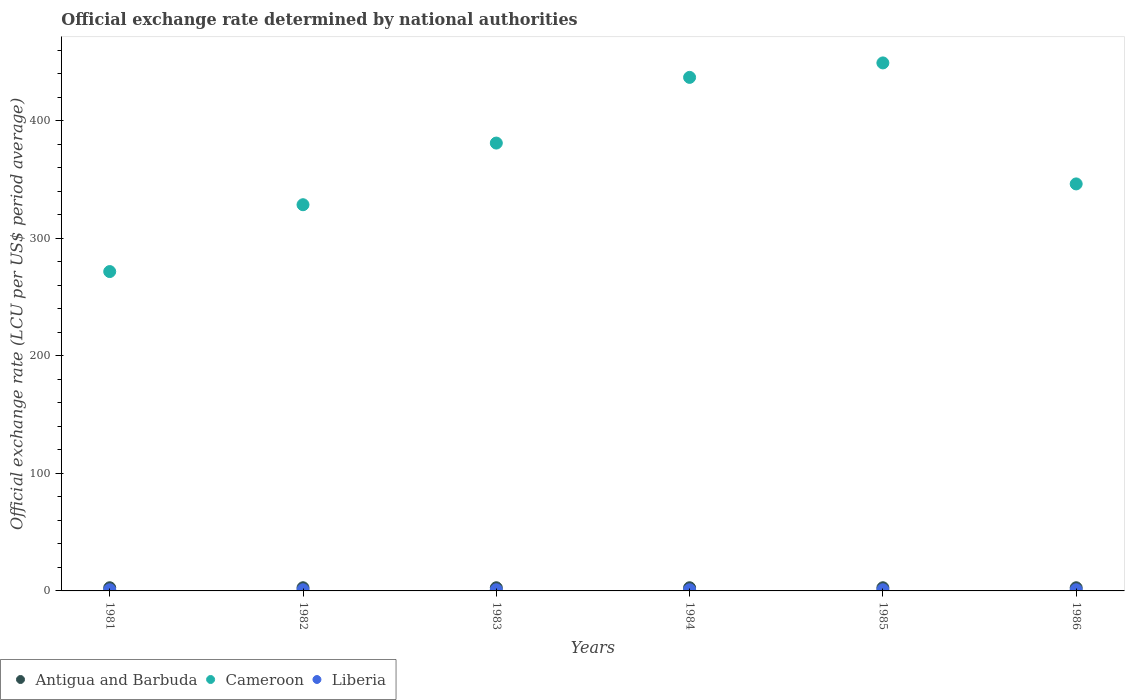What is the official exchange rate in Liberia in 1984?
Your answer should be compact. 1. Across all years, what is the maximum official exchange rate in Cameroon?
Your answer should be compact. 449.26. Across all years, what is the minimum official exchange rate in Liberia?
Offer a terse response. 1. In which year was the official exchange rate in Antigua and Barbuda maximum?
Your answer should be very brief. 1981. In which year was the official exchange rate in Antigua and Barbuda minimum?
Make the answer very short. 1981. What is the difference between the official exchange rate in Liberia in 1986 and the official exchange rate in Cameroon in 1982?
Your response must be concise. -327.61. What is the average official exchange rate in Liberia per year?
Provide a short and direct response. 1. In the year 1984, what is the difference between the official exchange rate in Antigua and Barbuda and official exchange rate in Cameroon?
Your response must be concise. -434.26. In how many years, is the official exchange rate in Liberia greater than 380 LCU?
Give a very brief answer. 0. What is the ratio of the official exchange rate in Cameroon in 1982 to that in 1985?
Ensure brevity in your answer.  0.73. What is the difference between the highest and the second highest official exchange rate in Antigua and Barbuda?
Ensure brevity in your answer.  0. What is the difference between the highest and the lowest official exchange rate in Antigua and Barbuda?
Your answer should be very brief. 0. In how many years, is the official exchange rate in Antigua and Barbuda greater than the average official exchange rate in Antigua and Barbuda taken over all years?
Provide a short and direct response. 6. Is it the case that in every year, the sum of the official exchange rate in Liberia and official exchange rate in Antigua and Barbuda  is greater than the official exchange rate in Cameroon?
Your answer should be compact. No. Does the official exchange rate in Antigua and Barbuda monotonically increase over the years?
Make the answer very short. No. How many years are there in the graph?
Your response must be concise. 6. What is the difference between two consecutive major ticks on the Y-axis?
Offer a very short reply. 100. Are the values on the major ticks of Y-axis written in scientific E-notation?
Provide a short and direct response. No. Does the graph contain any zero values?
Your answer should be compact. No. Where does the legend appear in the graph?
Offer a terse response. Bottom left. How are the legend labels stacked?
Your response must be concise. Horizontal. What is the title of the graph?
Make the answer very short. Official exchange rate determined by national authorities. What is the label or title of the Y-axis?
Offer a very short reply. Official exchange rate (LCU per US$ period average). What is the Official exchange rate (LCU per US$ period average) of Cameroon in 1981?
Give a very brief answer. 271.73. What is the Official exchange rate (LCU per US$ period average) in Liberia in 1981?
Make the answer very short. 1. What is the Official exchange rate (LCU per US$ period average) in Antigua and Barbuda in 1982?
Make the answer very short. 2.7. What is the Official exchange rate (LCU per US$ period average) of Cameroon in 1982?
Offer a terse response. 328.61. What is the Official exchange rate (LCU per US$ period average) of Liberia in 1982?
Keep it short and to the point. 1. What is the Official exchange rate (LCU per US$ period average) of Antigua and Barbuda in 1983?
Offer a very short reply. 2.7. What is the Official exchange rate (LCU per US$ period average) in Cameroon in 1983?
Offer a very short reply. 381.07. What is the Official exchange rate (LCU per US$ period average) of Liberia in 1983?
Offer a terse response. 1. What is the Official exchange rate (LCU per US$ period average) in Cameroon in 1984?
Ensure brevity in your answer.  436.96. What is the Official exchange rate (LCU per US$ period average) of Liberia in 1984?
Provide a short and direct response. 1. What is the Official exchange rate (LCU per US$ period average) of Antigua and Barbuda in 1985?
Your answer should be compact. 2.7. What is the Official exchange rate (LCU per US$ period average) in Cameroon in 1985?
Keep it short and to the point. 449.26. What is the Official exchange rate (LCU per US$ period average) of Liberia in 1985?
Keep it short and to the point. 1. What is the Official exchange rate (LCU per US$ period average) of Antigua and Barbuda in 1986?
Provide a succinct answer. 2.7. What is the Official exchange rate (LCU per US$ period average) in Cameroon in 1986?
Keep it short and to the point. 346.31. What is the Official exchange rate (LCU per US$ period average) in Liberia in 1986?
Give a very brief answer. 1. Across all years, what is the maximum Official exchange rate (LCU per US$ period average) of Cameroon?
Your answer should be very brief. 449.26. Across all years, what is the maximum Official exchange rate (LCU per US$ period average) of Liberia?
Keep it short and to the point. 1. Across all years, what is the minimum Official exchange rate (LCU per US$ period average) in Antigua and Barbuda?
Ensure brevity in your answer.  2.7. Across all years, what is the minimum Official exchange rate (LCU per US$ period average) in Cameroon?
Provide a short and direct response. 271.73. Across all years, what is the minimum Official exchange rate (LCU per US$ period average) of Liberia?
Offer a very short reply. 1. What is the total Official exchange rate (LCU per US$ period average) of Cameroon in the graph?
Ensure brevity in your answer.  2213.93. What is the difference between the Official exchange rate (LCU per US$ period average) of Antigua and Barbuda in 1981 and that in 1982?
Your answer should be very brief. 0. What is the difference between the Official exchange rate (LCU per US$ period average) in Cameroon in 1981 and that in 1982?
Provide a short and direct response. -56.87. What is the difference between the Official exchange rate (LCU per US$ period average) of Cameroon in 1981 and that in 1983?
Give a very brief answer. -109.33. What is the difference between the Official exchange rate (LCU per US$ period average) of Cameroon in 1981 and that in 1984?
Offer a very short reply. -165.23. What is the difference between the Official exchange rate (LCU per US$ period average) in Antigua and Barbuda in 1981 and that in 1985?
Your response must be concise. 0. What is the difference between the Official exchange rate (LCU per US$ period average) in Cameroon in 1981 and that in 1985?
Offer a terse response. -177.53. What is the difference between the Official exchange rate (LCU per US$ period average) of Liberia in 1981 and that in 1985?
Provide a short and direct response. -0. What is the difference between the Official exchange rate (LCU per US$ period average) in Cameroon in 1981 and that in 1986?
Ensure brevity in your answer.  -74.57. What is the difference between the Official exchange rate (LCU per US$ period average) of Cameroon in 1982 and that in 1983?
Ensure brevity in your answer.  -52.46. What is the difference between the Official exchange rate (LCU per US$ period average) of Liberia in 1982 and that in 1983?
Your response must be concise. 0. What is the difference between the Official exchange rate (LCU per US$ period average) of Cameroon in 1982 and that in 1984?
Provide a short and direct response. -108.35. What is the difference between the Official exchange rate (LCU per US$ period average) of Antigua and Barbuda in 1982 and that in 1985?
Provide a succinct answer. 0. What is the difference between the Official exchange rate (LCU per US$ period average) in Cameroon in 1982 and that in 1985?
Your response must be concise. -120.66. What is the difference between the Official exchange rate (LCU per US$ period average) in Cameroon in 1982 and that in 1986?
Make the answer very short. -17.7. What is the difference between the Official exchange rate (LCU per US$ period average) in Cameroon in 1983 and that in 1984?
Give a very brief answer. -55.89. What is the difference between the Official exchange rate (LCU per US$ period average) of Liberia in 1983 and that in 1984?
Provide a succinct answer. -0. What is the difference between the Official exchange rate (LCU per US$ period average) of Antigua and Barbuda in 1983 and that in 1985?
Offer a very short reply. 0. What is the difference between the Official exchange rate (LCU per US$ period average) of Cameroon in 1983 and that in 1985?
Your answer should be very brief. -68.2. What is the difference between the Official exchange rate (LCU per US$ period average) in Liberia in 1983 and that in 1985?
Give a very brief answer. -0. What is the difference between the Official exchange rate (LCU per US$ period average) in Cameroon in 1983 and that in 1986?
Offer a terse response. 34.76. What is the difference between the Official exchange rate (LCU per US$ period average) of Cameroon in 1984 and that in 1985?
Your answer should be compact. -12.31. What is the difference between the Official exchange rate (LCU per US$ period average) of Liberia in 1984 and that in 1985?
Your response must be concise. -0. What is the difference between the Official exchange rate (LCU per US$ period average) in Cameroon in 1984 and that in 1986?
Your answer should be very brief. 90.65. What is the difference between the Official exchange rate (LCU per US$ period average) in Cameroon in 1985 and that in 1986?
Ensure brevity in your answer.  102.96. What is the difference between the Official exchange rate (LCU per US$ period average) in Liberia in 1985 and that in 1986?
Offer a terse response. 0. What is the difference between the Official exchange rate (LCU per US$ period average) of Antigua and Barbuda in 1981 and the Official exchange rate (LCU per US$ period average) of Cameroon in 1982?
Ensure brevity in your answer.  -325.91. What is the difference between the Official exchange rate (LCU per US$ period average) of Antigua and Barbuda in 1981 and the Official exchange rate (LCU per US$ period average) of Liberia in 1982?
Provide a short and direct response. 1.7. What is the difference between the Official exchange rate (LCU per US$ period average) in Cameroon in 1981 and the Official exchange rate (LCU per US$ period average) in Liberia in 1982?
Provide a short and direct response. 270.73. What is the difference between the Official exchange rate (LCU per US$ period average) of Antigua and Barbuda in 1981 and the Official exchange rate (LCU per US$ period average) of Cameroon in 1983?
Provide a short and direct response. -378.37. What is the difference between the Official exchange rate (LCU per US$ period average) in Cameroon in 1981 and the Official exchange rate (LCU per US$ period average) in Liberia in 1983?
Offer a very short reply. 270.73. What is the difference between the Official exchange rate (LCU per US$ period average) in Antigua and Barbuda in 1981 and the Official exchange rate (LCU per US$ period average) in Cameroon in 1984?
Provide a short and direct response. -434.26. What is the difference between the Official exchange rate (LCU per US$ period average) of Antigua and Barbuda in 1981 and the Official exchange rate (LCU per US$ period average) of Liberia in 1984?
Give a very brief answer. 1.7. What is the difference between the Official exchange rate (LCU per US$ period average) in Cameroon in 1981 and the Official exchange rate (LCU per US$ period average) in Liberia in 1984?
Your answer should be compact. 270.73. What is the difference between the Official exchange rate (LCU per US$ period average) of Antigua and Barbuda in 1981 and the Official exchange rate (LCU per US$ period average) of Cameroon in 1985?
Provide a short and direct response. -446.56. What is the difference between the Official exchange rate (LCU per US$ period average) in Antigua and Barbuda in 1981 and the Official exchange rate (LCU per US$ period average) in Liberia in 1985?
Keep it short and to the point. 1.7. What is the difference between the Official exchange rate (LCU per US$ period average) in Cameroon in 1981 and the Official exchange rate (LCU per US$ period average) in Liberia in 1985?
Your response must be concise. 270.73. What is the difference between the Official exchange rate (LCU per US$ period average) in Antigua and Barbuda in 1981 and the Official exchange rate (LCU per US$ period average) in Cameroon in 1986?
Offer a very short reply. -343.61. What is the difference between the Official exchange rate (LCU per US$ period average) in Cameroon in 1981 and the Official exchange rate (LCU per US$ period average) in Liberia in 1986?
Your answer should be very brief. 270.73. What is the difference between the Official exchange rate (LCU per US$ period average) in Antigua and Barbuda in 1982 and the Official exchange rate (LCU per US$ period average) in Cameroon in 1983?
Keep it short and to the point. -378.37. What is the difference between the Official exchange rate (LCU per US$ period average) of Antigua and Barbuda in 1982 and the Official exchange rate (LCU per US$ period average) of Liberia in 1983?
Make the answer very short. 1.7. What is the difference between the Official exchange rate (LCU per US$ period average) of Cameroon in 1982 and the Official exchange rate (LCU per US$ period average) of Liberia in 1983?
Make the answer very short. 327.61. What is the difference between the Official exchange rate (LCU per US$ period average) of Antigua and Barbuda in 1982 and the Official exchange rate (LCU per US$ period average) of Cameroon in 1984?
Offer a terse response. -434.26. What is the difference between the Official exchange rate (LCU per US$ period average) of Antigua and Barbuda in 1982 and the Official exchange rate (LCU per US$ period average) of Liberia in 1984?
Your answer should be compact. 1.7. What is the difference between the Official exchange rate (LCU per US$ period average) of Cameroon in 1982 and the Official exchange rate (LCU per US$ period average) of Liberia in 1984?
Make the answer very short. 327.61. What is the difference between the Official exchange rate (LCU per US$ period average) in Antigua and Barbuda in 1982 and the Official exchange rate (LCU per US$ period average) in Cameroon in 1985?
Your answer should be very brief. -446.56. What is the difference between the Official exchange rate (LCU per US$ period average) in Cameroon in 1982 and the Official exchange rate (LCU per US$ period average) in Liberia in 1985?
Your answer should be compact. 327.61. What is the difference between the Official exchange rate (LCU per US$ period average) in Antigua and Barbuda in 1982 and the Official exchange rate (LCU per US$ period average) in Cameroon in 1986?
Your answer should be compact. -343.61. What is the difference between the Official exchange rate (LCU per US$ period average) of Cameroon in 1982 and the Official exchange rate (LCU per US$ period average) of Liberia in 1986?
Give a very brief answer. 327.61. What is the difference between the Official exchange rate (LCU per US$ period average) of Antigua and Barbuda in 1983 and the Official exchange rate (LCU per US$ period average) of Cameroon in 1984?
Your response must be concise. -434.26. What is the difference between the Official exchange rate (LCU per US$ period average) of Antigua and Barbuda in 1983 and the Official exchange rate (LCU per US$ period average) of Liberia in 1984?
Your answer should be very brief. 1.7. What is the difference between the Official exchange rate (LCU per US$ period average) of Cameroon in 1983 and the Official exchange rate (LCU per US$ period average) of Liberia in 1984?
Ensure brevity in your answer.  380.07. What is the difference between the Official exchange rate (LCU per US$ period average) in Antigua and Barbuda in 1983 and the Official exchange rate (LCU per US$ period average) in Cameroon in 1985?
Your answer should be compact. -446.56. What is the difference between the Official exchange rate (LCU per US$ period average) of Antigua and Barbuda in 1983 and the Official exchange rate (LCU per US$ period average) of Liberia in 1985?
Make the answer very short. 1.7. What is the difference between the Official exchange rate (LCU per US$ period average) of Cameroon in 1983 and the Official exchange rate (LCU per US$ period average) of Liberia in 1985?
Offer a terse response. 380.07. What is the difference between the Official exchange rate (LCU per US$ period average) in Antigua and Barbuda in 1983 and the Official exchange rate (LCU per US$ period average) in Cameroon in 1986?
Provide a short and direct response. -343.61. What is the difference between the Official exchange rate (LCU per US$ period average) in Antigua and Barbuda in 1983 and the Official exchange rate (LCU per US$ period average) in Liberia in 1986?
Keep it short and to the point. 1.7. What is the difference between the Official exchange rate (LCU per US$ period average) in Cameroon in 1983 and the Official exchange rate (LCU per US$ period average) in Liberia in 1986?
Keep it short and to the point. 380.07. What is the difference between the Official exchange rate (LCU per US$ period average) in Antigua and Barbuda in 1984 and the Official exchange rate (LCU per US$ period average) in Cameroon in 1985?
Give a very brief answer. -446.56. What is the difference between the Official exchange rate (LCU per US$ period average) of Antigua and Barbuda in 1984 and the Official exchange rate (LCU per US$ period average) of Liberia in 1985?
Make the answer very short. 1.7. What is the difference between the Official exchange rate (LCU per US$ period average) of Cameroon in 1984 and the Official exchange rate (LCU per US$ period average) of Liberia in 1985?
Keep it short and to the point. 435.96. What is the difference between the Official exchange rate (LCU per US$ period average) in Antigua and Barbuda in 1984 and the Official exchange rate (LCU per US$ period average) in Cameroon in 1986?
Give a very brief answer. -343.61. What is the difference between the Official exchange rate (LCU per US$ period average) in Antigua and Barbuda in 1984 and the Official exchange rate (LCU per US$ period average) in Liberia in 1986?
Provide a succinct answer. 1.7. What is the difference between the Official exchange rate (LCU per US$ period average) of Cameroon in 1984 and the Official exchange rate (LCU per US$ period average) of Liberia in 1986?
Offer a terse response. 435.96. What is the difference between the Official exchange rate (LCU per US$ period average) of Antigua and Barbuda in 1985 and the Official exchange rate (LCU per US$ period average) of Cameroon in 1986?
Provide a short and direct response. -343.61. What is the difference between the Official exchange rate (LCU per US$ period average) of Antigua and Barbuda in 1985 and the Official exchange rate (LCU per US$ period average) of Liberia in 1986?
Give a very brief answer. 1.7. What is the difference between the Official exchange rate (LCU per US$ period average) of Cameroon in 1985 and the Official exchange rate (LCU per US$ period average) of Liberia in 1986?
Your answer should be compact. 448.26. What is the average Official exchange rate (LCU per US$ period average) of Antigua and Barbuda per year?
Your answer should be very brief. 2.7. What is the average Official exchange rate (LCU per US$ period average) of Cameroon per year?
Ensure brevity in your answer.  368.99. What is the average Official exchange rate (LCU per US$ period average) in Liberia per year?
Offer a terse response. 1. In the year 1981, what is the difference between the Official exchange rate (LCU per US$ period average) in Antigua and Barbuda and Official exchange rate (LCU per US$ period average) in Cameroon?
Make the answer very short. -269.03. In the year 1981, what is the difference between the Official exchange rate (LCU per US$ period average) of Antigua and Barbuda and Official exchange rate (LCU per US$ period average) of Liberia?
Provide a succinct answer. 1.7. In the year 1981, what is the difference between the Official exchange rate (LCU per US$ period average) in Cameroon and Official exchange rate (LCU per US$ period average) in Liberia?
Your response must be concise. 270.73. In the year 1982, what is the difference between the Official exchange rate (LCU per US$ period average) in Antigua and Barbuda and Official exchange rate (LCU per US$ period average) in Cameroon?
Your answer should be very brief. -325.91. In the year 1982, what is the difference between the Official exchange rate (LCU per US$ period average) in Cameroon and Official exchange rate (LCU per US$ period average) in Liberia?
Provide a succinct answer. 327.61. In the year 1983, what is the difference between the Official exchange rate (LCU per US$ period average) in Antigua and Barbuda and Official exchange rate (LCU per US$ period average) in Cameroon?
Provide a succinct answer. -378.37. In the year 1983, what is the difference between the Official exchange rate (LCU per US$ period average) in Cameroon and Official exchange rate (LCU per US$ period average) in Liberia?
Give a very brief answer. 380.07. In the year 1984, what is the difference between the Official exchange rate (LCU per US$ period average) in Antigua and Barbuda and Official exchange rate (LCU per US$ period average) in Cameroon?
Make the answer very short. -434.26. In the year 1984, what is the difference between the Official exchange rate (LCU per US$ period average) of Cameroon and Official exchange rate (LCU per US$ period average) of Liberia?
Your response must be concise. 435.96. In the year 1985, what is the difference between the Official exchange rate (LCU per US$ period average) of Antigua and Barbuda and Official exchange rate (LCU per US$ period average) of Cameroon?
Make the answer very short. -446.56. In the year 1985, what is the difference between the Official exchange rate (LCU per US$ period average) of Cameroon and Official exchange rate (LCU per US$ period average) of Liberia?
Offer a terse response. 448.26. In the year 1986, what is the difference between the Official exchange rate (LCU per US$ period average) of Antigua and Barbuda and Official exchange rate (LCU per US$ period average) of Cameroon?
Provide a succinct answer. -343.61. In the year 1986, what is the difference between the Official exchange rate (LCU per US$ period average) in Antigua and Barbuda and Official exchange rate (LCU per US$ period average) in Liberia?
Ensure brevity in your answer.  1.7. In the year 1986, what is the difference between the Official exchange rate (LCU per US$ period average) in Cameroon and Official exchange rate (LCU per US$ period average) in Liberia?
Offer a very short reply. 345.31. What is the ratio of the Official exchange rate (LCU per US$ period average) in Cameroon in 1981 to that in 1982?
Offer a very short reply. 0.83. What is the ratio of the Official exchange rate (LCU per US$ period average) of Cameroon in 1981 to that in 1983?
Give a very brief answer. 0.71. What is the ratio of the Official exchange rate (LCU per US$ period average) in Antigua and Barbuda in 1981 to that in 1984?
Your answer should be very brief. 1. What is the ratio of the Official exchange rate (LCU per US$ period average) of Cameroon in 1981 to that in 1984?
Give a very brief answer. 0.62. What is the ratio of the Official exchange rate (LCU per US$ period average) of Liberia in 1981 to that in 1984?
Your answer should be very brief. 1. What is the ratio of the Official exchange rate (LCU per US$ period average) of Cameroon in 1981 to that in 1985?
Your answer should be very brief. 0.6. What is the ratio of the Official exchange rate (LCU per US$ period average) of Liberia in 1981 to that in 1985?
Give a very brief answer. 1. What is the ratio of the Official exchange rate (LCU per US$ period average) of Cameroon in 1981 to that in 1986?
Ensure brevity in your answer.  0.78. What is the ratio of the Official exchange rate (LCU per US$ period average) of Antigua and Barbuda in 1982 to that in 1983?
Keep it short and to the point. 1. What is the ratio of the Official exchange rate (LCU per US$ period average) in Cameroon in 1982 to that in 1983?
Your answer should be very brief. 0.86. What is the ratio of the Official exchange rate (LCU per US$ period average) of Liberia in 1982 to that in 1983?
Your answer should be compact. 1. What is the ratio of the Official exchange rate (LCU per US$ period average) of Antigua and Barbuda in 1982 to that in 1984?
Offer a terse response. 1. What is the ratio of the Official exchange rate (LCU per US$ period average) in Cameroon in 1982 to that in 1984?
Provide a short and direct response. 0.75. What is the ratio of the Official exchange rate (LCU per US$ period average) in Liberia in 1982 to that in 1984?
Ensure brevity in your answer.  1. What is the ratio of the Official exchange rate (LCU per US$ period average) of Cameroon in 1982 to that in 1985?
Provide a short and direct response. 0.73. What is the ratio of the Official exchange rate (LCU per US$ period average) of Liberia in 1982 to that in 1985?
Provide a short and direct response. 1. What is the ratio of the Official exchange rate (LCU per US$ period average) of Cameroon in 1982 to that in 1986?
Your answer should be very brief. 0.95. What is the ratio of the Official exchange rate (LCU per US$ period average) in Cameroon in 1983 to that in 1984?
Offer a terse response. 0.87. What is the ratio of the Official exchange rate (LCU per US$ period average) of Antigua and Barbuda in 1983 to that in 1985?
Your answer should be very brief. 1. What is the ratio of the Official exchange rate (LCU per US$ period average) in Cameroon in 1983 to that in 1985?
Your answer should be compact. 0.85. What is the ratio of the Official exchange rate (LCU per US$ period average) in Antigua and Barbuda in 1983 to that in 1986?
Your response must be concise. 1. What is the ratio of the Official exchange rate (LCU per US$ period average) in Cameroon in 1983 to that in 1986?
Ensure brevity in your answer.  1.1. What is the ratio of the Official exchange rate (LCU per US$ period average) in Liberia in 1983 to that in 1986?
Offer a very short reply. 1. What is the ratio of the Official exchange rate (LCU per US$ period average) of Cameroon in 1984 to that in 1985?
Make the answer very short. 0.97. What is the ratio of the Official exchange rate (LCU per US$ period average) of Liberia in 1984 to that in 1985?
Ensure brevity in your answer.  1. What is the ratio of the Official exchange rate (LCU per US$ period average) in Antigua and Barbuda in 1984 to that in 1986?
Offer a very short reply. 1. What is the ratio of the Official exchange rate (LCU per US$ period average) in Cameroon in 1984 to that in 1986?
Keep it short and to the point. 1.26. What is the ratio of the Official exchange rate (LCU per US$ period average) of Liberia in 1984 to that in 1986?
Make the answer very short. 1. What is the ratio of the Official exchange rate (LCU per US$ period average) of Antigua and Barbuda in 1985 to that in 1986?
Provide a short and direct response. 1. What is the ratio of the Official exchange rate (LCU per US$ period average) in Cameroon in 1985 to that in 1986?
Offer a very short reply. 1.3. What is the difference between the highest and the second highest Official exchange rate (LCU per US$ period average) of Cameroon?
Provide a succinct answer. 12.31. What is the difference between the highest and the second highest Official exchange rate (LCU per US$ period average) of Liberia?
Make the answer very short. 0. What is the difference between the highest and the lowest Official exchange rate (LCU per US$ period average) in Antigua and Barbuda?
Give a very brief answer. 0. What is the difference between the highest and the lowest Official exchange rate (LCU per US$ period average) in Cameroon?
Ensure brevity in your answer.  177.53. 